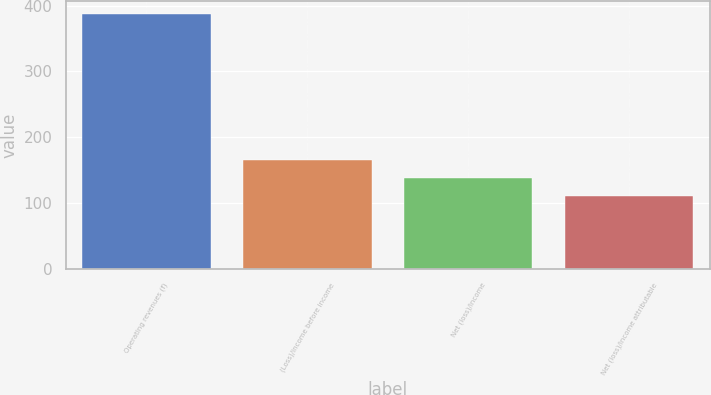Convert chart to OTSL. <chart><loc_0><loc_0><loc_500><loc_500><bar_chart><fcel>Operating revenues (f)<fcel>(Loss)/income before income<fcel>Net (loss)/income<fcel>Net (loss)/income attributable<nl><fcel>387<fcel>165.4<fcel>137.7<fcel>110<nl></chart> 